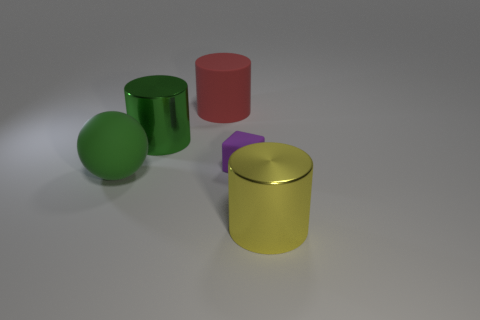Subtract all large yellow cylinders. How many cylinders are left? 2 Subtract 1 cylinders. How many cylinders are left? 2 Subtract all blue spheres. Subtract all cyan blocks. How many spheres are left? 1 Subtract all green cubes. How many red cylinders are left? 1 Subtract all tiny purple matte cubes. Subtract all big shiny cylinders. How many objects are left? 2 Add 2 rubber cubes. How many rubber cubes are left? 3 Add 3 large yellow matte cylinders. How many large yellow matte cylinders exist? 3 Add 3 large cylinders. How many objects exist? 8 Subtract all red cylinders. How many cylinders are left? 2 Subtract 1 yellow cylinders. How many objects are left? 4 